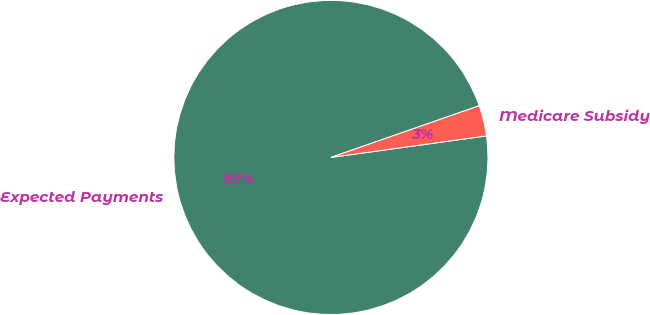<chart> <loc_0><loc_0><loc_500><loc_500><pie_chart><fcel>Expected Payments<fcel>Medicare Subsidy<nl><fcel>96.85%<fcel>3.15%<nl></chart> 